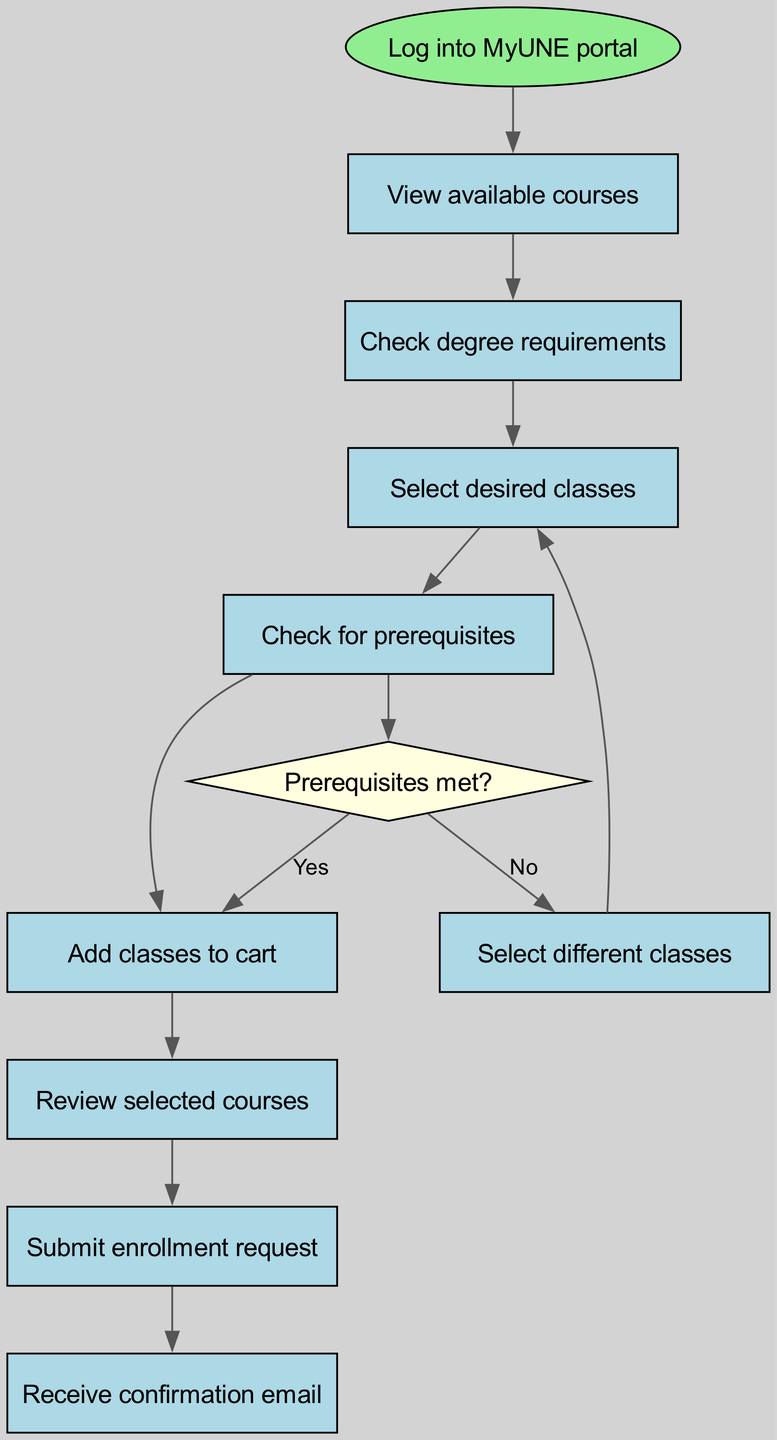What is the first step in the enrollment process? According to the diagram, the first step is to log into the MyUNE portal. This is indicated by the starting node that initiates the flowchart.
Answer: Log into MyUNE portal How many nodes are present in the diagram? By counting the nodes listed in the diagram, there are a total of 8 nodes. This includes the start node and all course enrollment steps.
Answer: 8 What node follows 'Review selected courses'? The diagram shows that after 'Review selected courses', the next step is to 'Submit enrollment request'. This would be the direct connection in the flow of the process.
Answer: Submit enrollment request What is the condition for proceeding to 'Add classes to cart'? The condition that must be met before adding classes to the cart is that prerequisites must be met. This is reflected in the decision node depicted in the flowchart.
Answer: Prerequisites met? What happens if the prerequisites are not met? If the prerequisites are not met, the flowchart indicates that the user should select different classes instead of proceeding to add classes to the cart, as noted in the decision path.
Answer: Select different classes How many edges are there connecting the various steps? Upon examining the edges that connect the nodes, there are a total of 7 edges in the diagram forming the paths of the enrollment process.
Answer: 7 What is the final step in the enrollment process? The last step in the enrollment process as shown by the final node in the diagram is to receive a confirmation email after submitting the enrollment request.
Answer: Receive confirmation email What decision is made regarding class selection? The decision regarding class selection is contingent on whether the prerequisites have been met, which determines whether to add classes to the cart or select different classes.
Answer: Prerequisites met? 